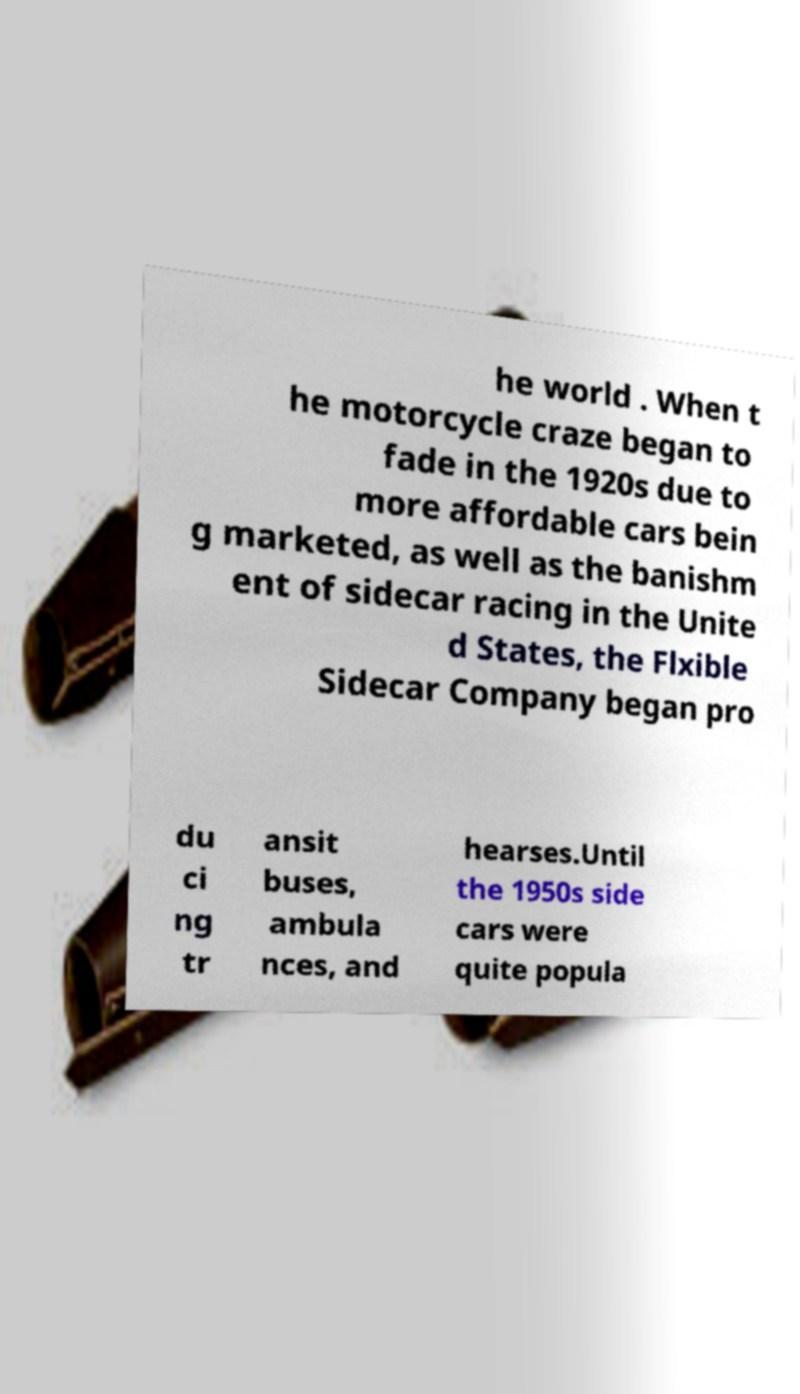For documentation purposes, I need the text within this image transcribed. Could you provide that? he world . When t he motorcycle craze began to fade in the 1920s due to more affordable cars bein g marketed, as well as the banishm ent of sidecar racing in the Unite d States, the Flxible Sidecar Company began pro du ci ng tr ansit buses, ambula nces, and hearses.Until the 1950s side cars were quite popula 